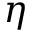<formula> <loc_0><loc_0><loc_500><loc_500>\eta</formula> 